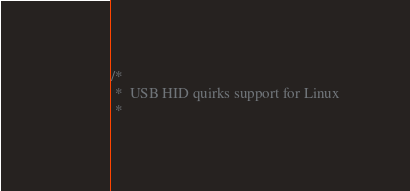<code> <loc_0><loc_0><loc_500><loc_500><_C_>/*
 *  USB HID quirks support for Linux
 *</code> 